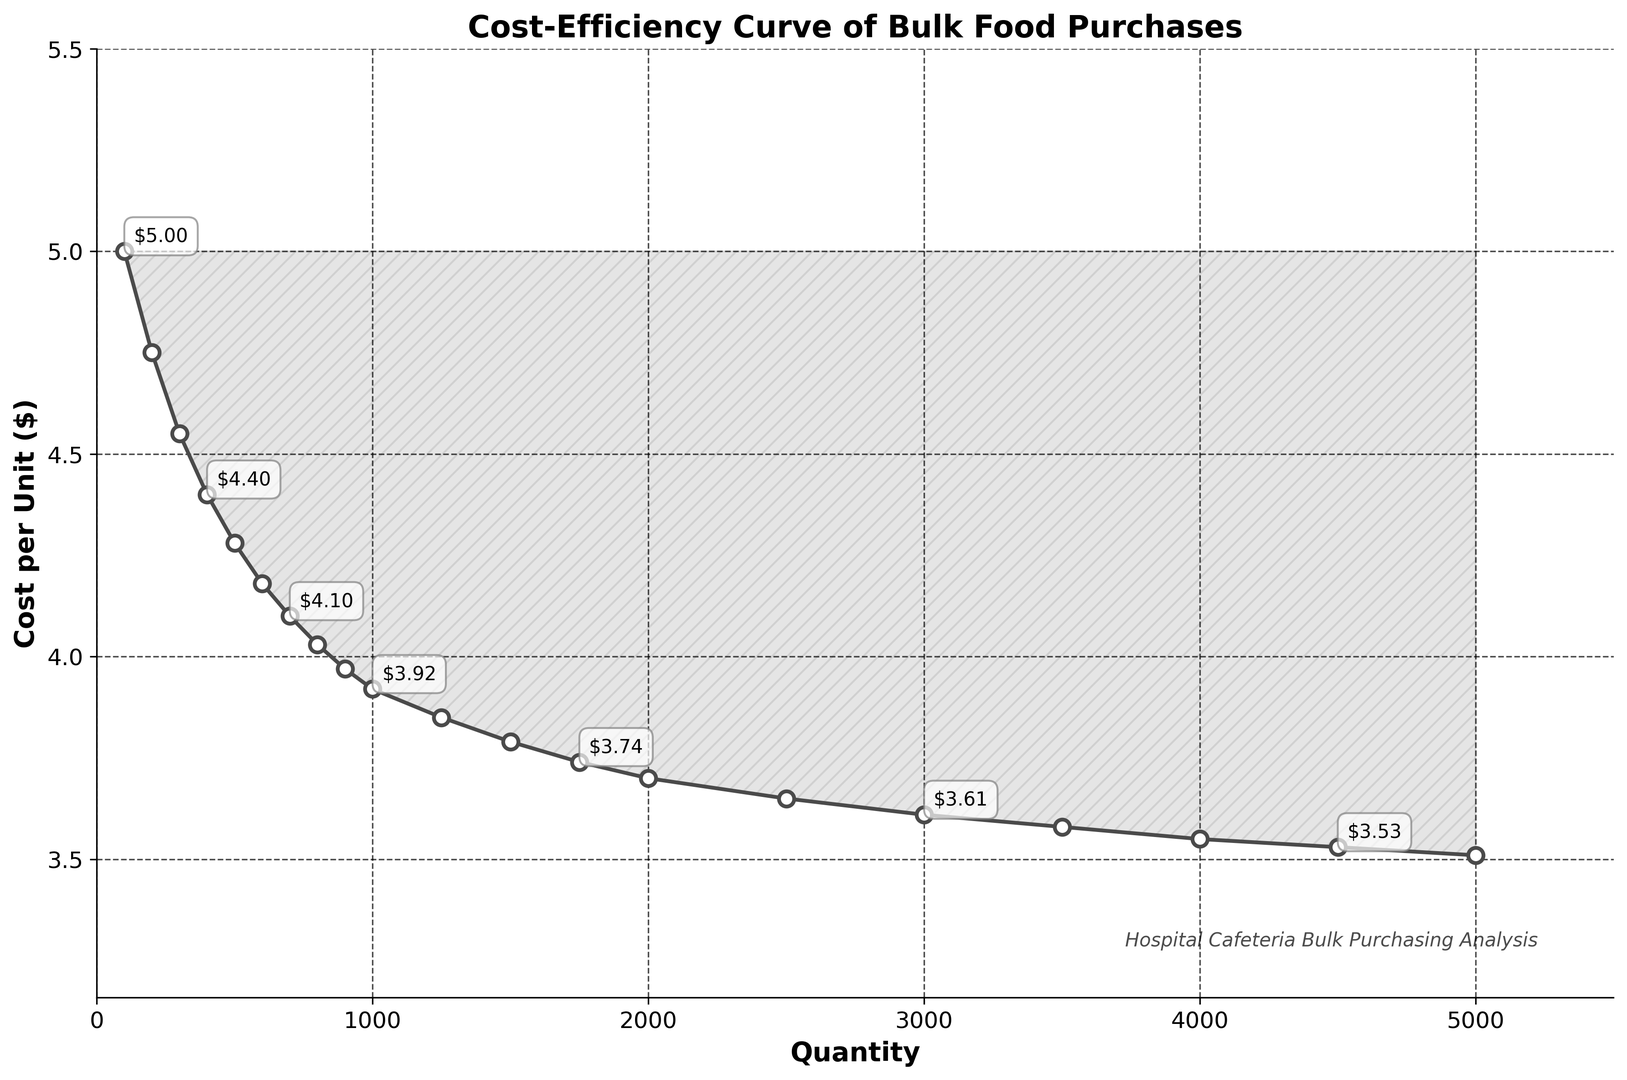What is the approximate cost per unit for a purchase quantity of 400 units? The plot shows the cost per unit on the y-axis and the purchase quantity on the x-axis. For 400 units, locate 400 on the x-axis and find the corresponding value on the curve.
Answer: $4.40 How much does the cost per unit decrease when the quantity increases from 1000 to 2000 units? Locate the cost per unit at 1000 units and at 2000 units. Subtract the cost at 2000 units from the cost at 1000 units.
Answer: $3.92 - $3.70 = $0.22 What is the trend of the cost per unit as the purchase quantity increases? By observing the curve, it is noticeable that the cost per unit gradually decreases as the quantity increases, showing a downward trend.
Answer: Decreasing Which quantity provides a cost per unit less than $4.00? Look along the curve and identify the quantities where the y-value (cost per unit) is less than $4.00. The first occurrence is at 700 units.
Answer: 700 units and above At what quantity does the cost per unit first drop below $3.80? Follow the curve and search for the first point where the cost per unit goes below $3.80. This happens at around 1500 units.
Answer: 1500 units What is the cost per unit for the largest quantity shown? Move to the rightmost point of the curve, which corresponds to the largest quantity (5000 units), and note the cost per unit there.
Answer: $3.51 How much does the cost per unit decrease from 3000 to 5000 units? Determine the cost per unit at 3000 units and 5000 units, then calculate the difference.
Answer: $3.61 - $3.51 = $0.10 Is the cost per unit more cost-efficient when purchasing 2500 units or 4000 units? Compare the cost per unit at 2500 units with the cost at 4000 units. Look for the lower value on the y-axis corresponding to each quantity.
Answer: 4000 units Calculate the average cost per unit for quantities of 1000, 2000, and 3000 units. Add the costs per unit for these quantities ($3.92, $3.70, and $3.61 respectively) and divide by 3 to find the average.
Answer: ($3.92 + $3.70 + $3.61) / 3 = $3.743 What visual element highlights the region where cost efficiencies are achieved in the plot? The region below the curve is shaded lightly, indicating where the cost efficiencies occur as the purchase quantity increases.
Answer: Shading under the curve 